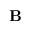<formula> <loc_0><loc_0><loc_500><loc_500>\mathbf B</formula> 